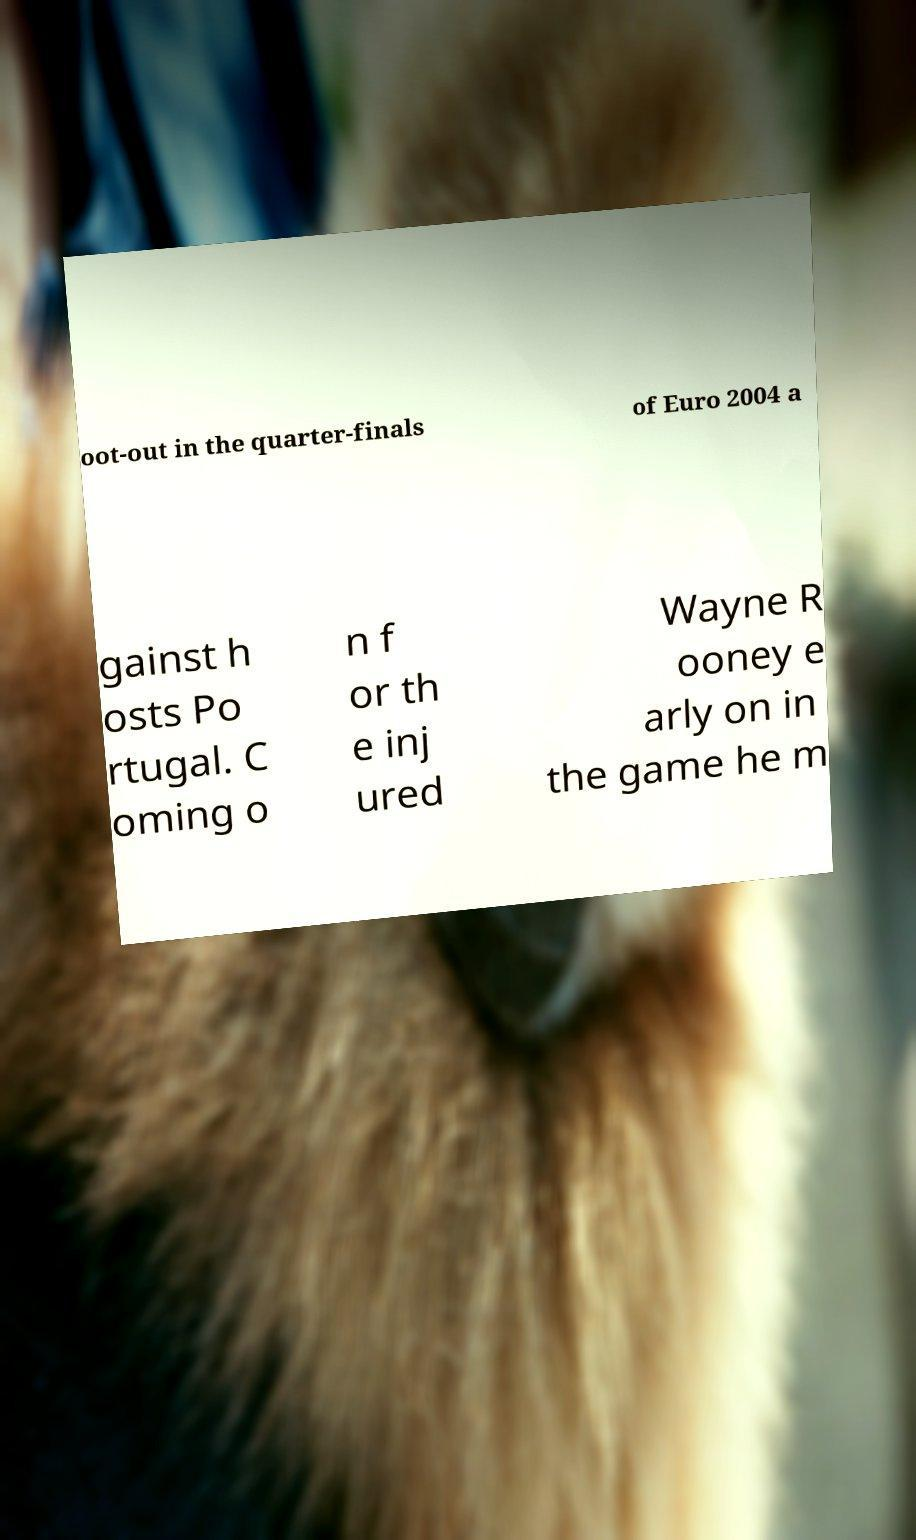Please identify and transcribe the text found in this image. oot-out in the quarter-finals of Euro 2004 a gainst h osts Po rtugal. C oming o n f or th e inj ured Wayne R ooney e arly on in the game he m 